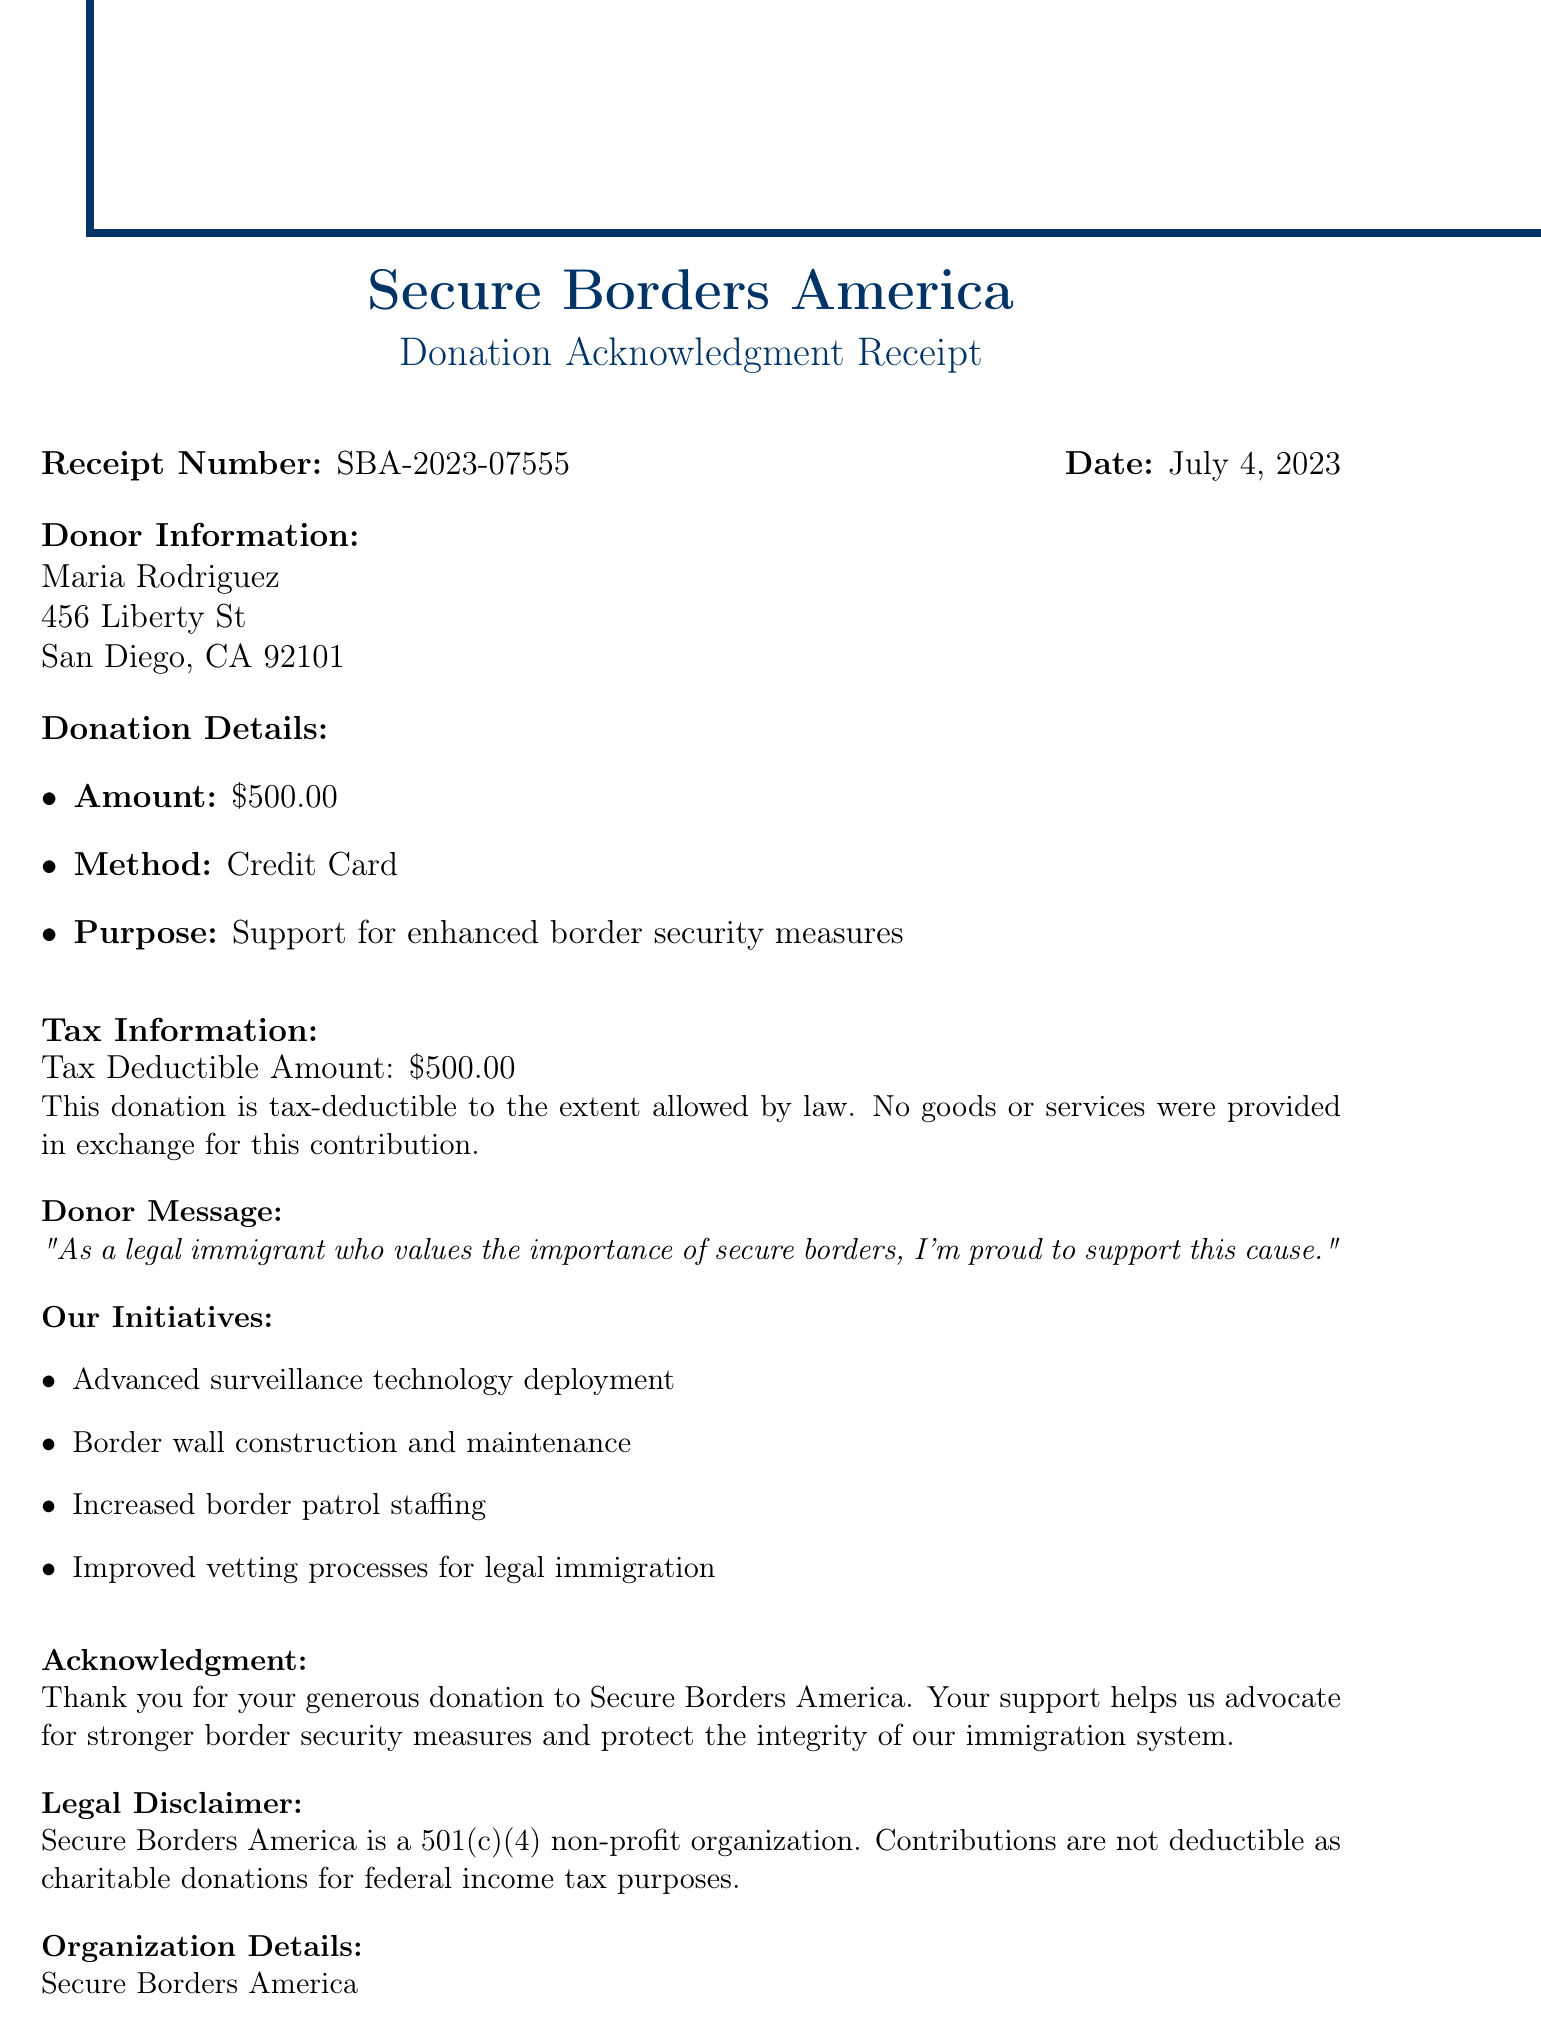What is the name of the organization? The organization's name is stated clearly at the top of the document.
Answer: Secure Borders America What is the donor's address? The donor's address is provided in the donor information section of the document.
Answer: 456 Liberty St, San Diego, CA 92101 How much was the donation? The amount of the donation is specified in the donation details section of the receipt.
Answer: $500.00 What is the tax deductible amount? The receipt specifies the tax deductible amount under the tax information section.
Answer: $500.00 What is the purpose of the donation? The purpose of the donation is indicated in the donation details on the document.
Answer: Support for enhanced border security measures What is the receipt number? The receipt number is mentioned at the top of the document for reference.
Answer: SBA-2023-07555 Who signed the acknowledgment? The authorized signature section indicates who signed the acknowledgment at the bottom of the document.
Answer: John Patriot What type of organization is Secure Borders America? This information is found in the legal disclaimer section of the document.
Answer: 501(c)(4) non-profit organization What is the donation date? The date of the donation is clearly stated in the header section of the document.
Answer: July 4, 2023 What initiatives does Secure Borders America support? The document lists specific initiatives under the Our Initiatives section.
Answer: Advanced surveillance technology deployment, Border wall construction and maintenance, Increased border patrol staffing, Improved vetting processes for legal immigration 